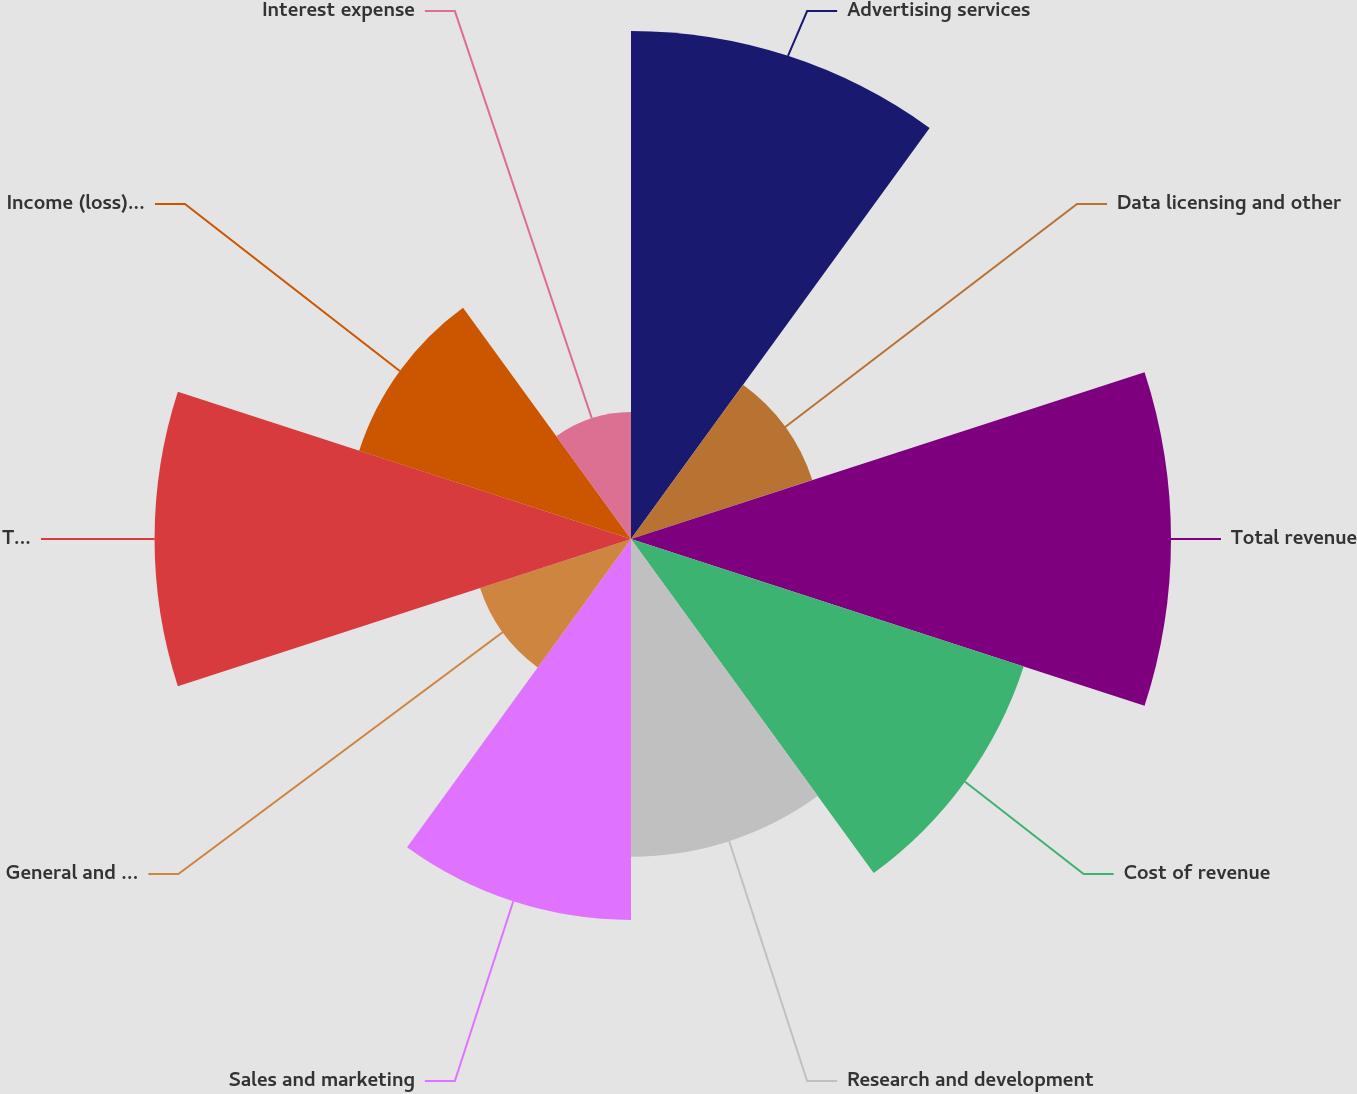<chart> <loc_0><loc_0><loc_500><loc_500><pie_chart><fcel>Advertising services<fcel>Data licensing and other<fcel>Total revenue<fcel>Cost of revenue<fcel>Research and development<fcel>Sales and marketing<fcel>General and administrative<fcel>Total costs and expenses<fcel>Income (loss) from operations<fcel>Interest expense<nl><fcel>14.95%<fcel>5.61%<fcel>15.89%<fcel>12.15%<fcel>9.35%<fcel>11.21%<fcel>4.67%<fcel>14.02%<fcel>8.41%<fcel>3.74%<nl></chart> 